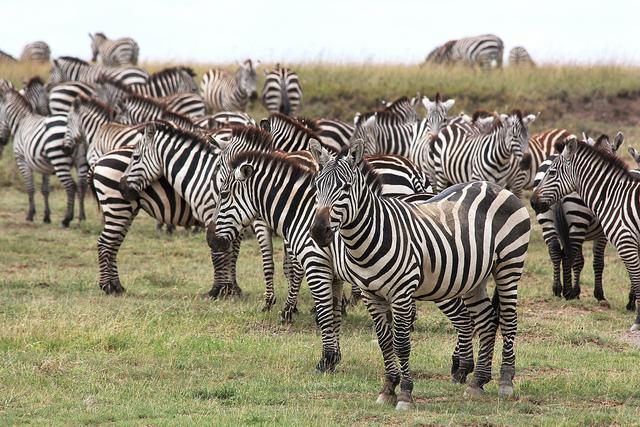Are these zebras considered a herd?
Be succinct. Yes. What color are these animals?
Give a very brief answer. Black and white. Do these animals have horns?
Answer briefly. No. 